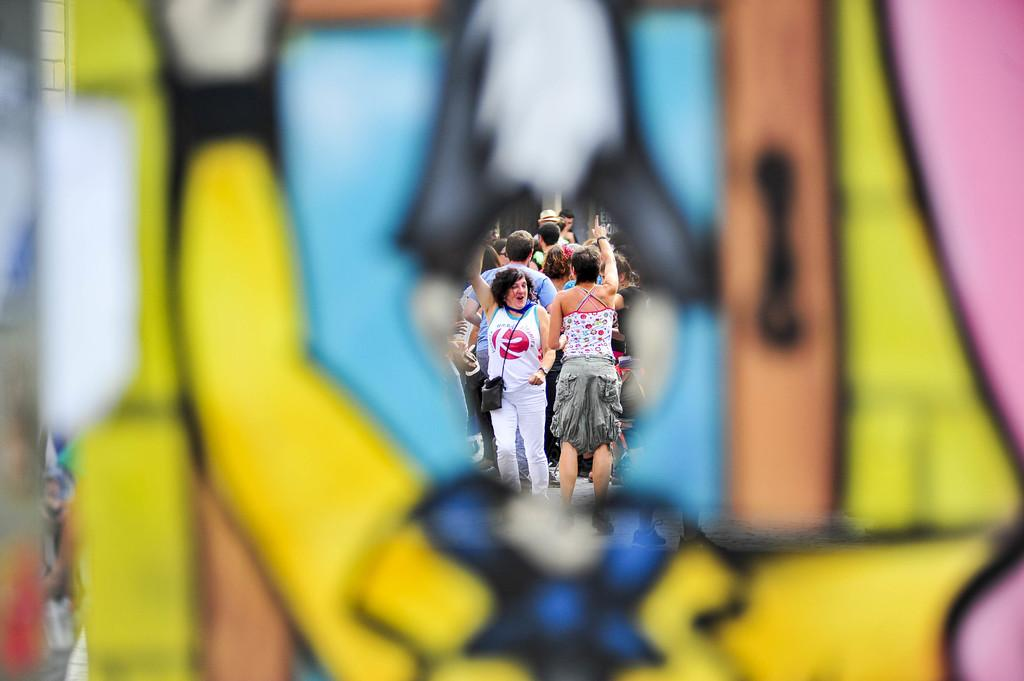What can be seen through the object in the image? People are visible through an object in the image. Can you describe the person wearing a sling bag in the image? There is a person wearing a sling bag in the image. What decision does the person in the crib make in the image? There is no crib or person making a decision present in the image. 